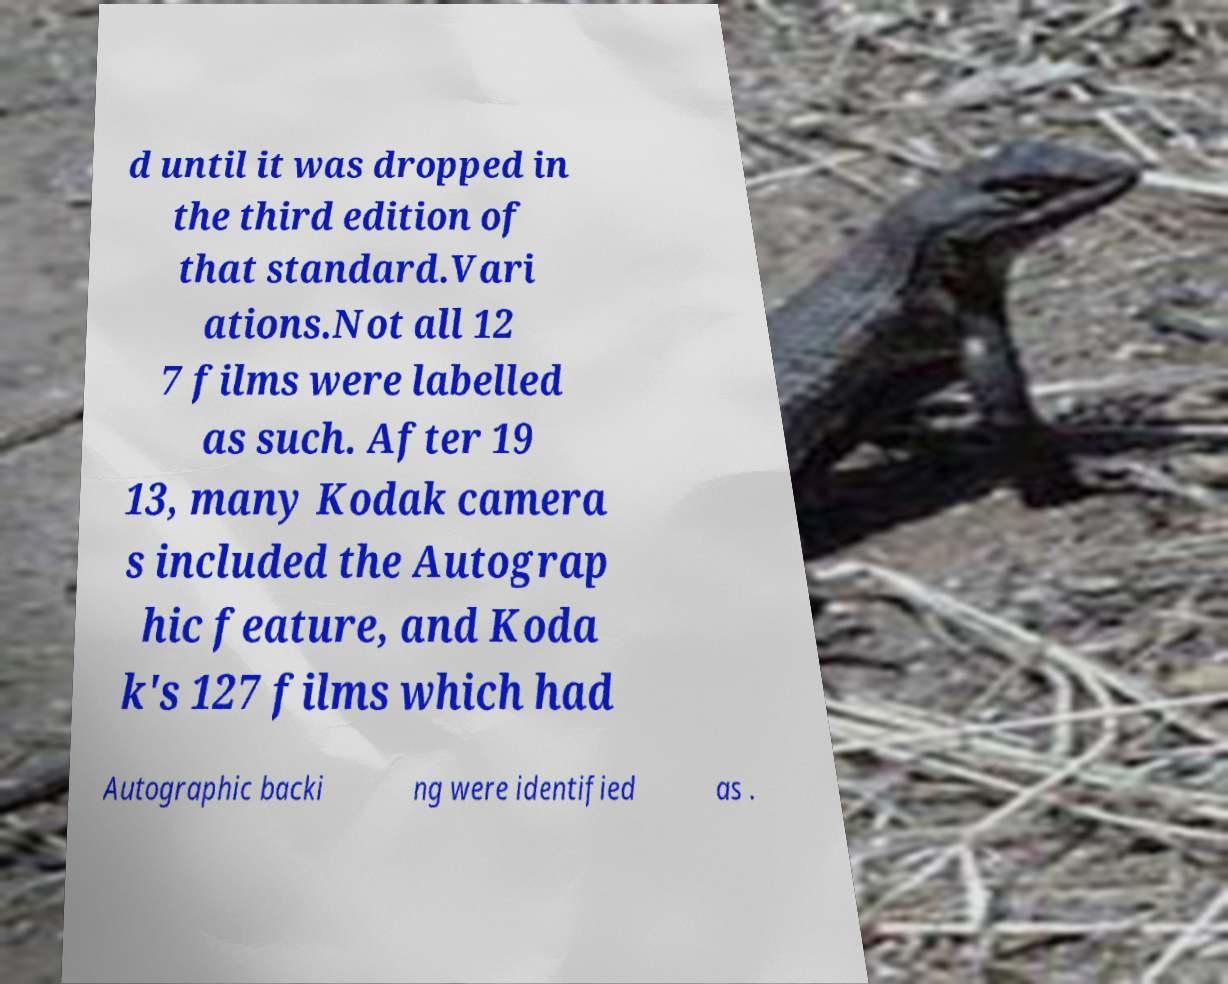There's text embedded in this image that I need extracted. Can you transcribe it verbatim? d until it was dropped in the third edition of that standard.Vari ations.Not all 12 7 films were labelled as such. After 19 13, many Kodak camera s included the Autograp hic feature, and Koda k's 127 films which had Autographic backi ng were identified as . 